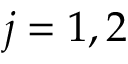<formula> <loc_0><loc_0><loc_500><loc_500>j = 1 , 2</formula> 